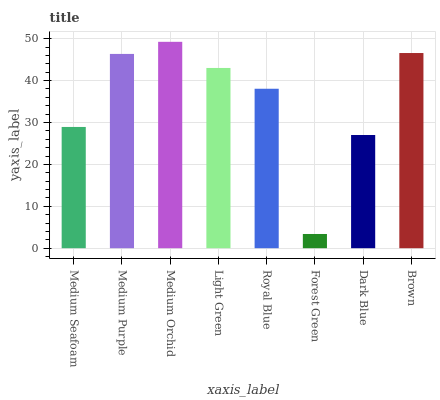Is Forest Green the minimum?
Answer yes or no. Yes. Is Medium Orchid the maximum?
Answer yes or no. Yes. Is Medium Purple the minimum?
Answer yes or no. No. Is Medium Purple the maximum?
Answer yes or no. No. Is Medium Purple greater than Medium Seafoam?
Answer yes or no. Yes. Is Medium Seafoam less than Medium Purple?
Answer yes or no. Yes. Is Medium Seafoam greater than Medium Purple?
Answer yes or no. No. Is Medium Purple less than Medium Seafoam?
Answer yes or no. No. Is Light Green the high median?
Answer yes or no. Yes. Is Royal Blue the low median?
Answer yes or no. Yes. Is Medium Purple the high median?
Answer yes or no. No. Is Medium Seafoam the low median?
Answer yes or no. No. 